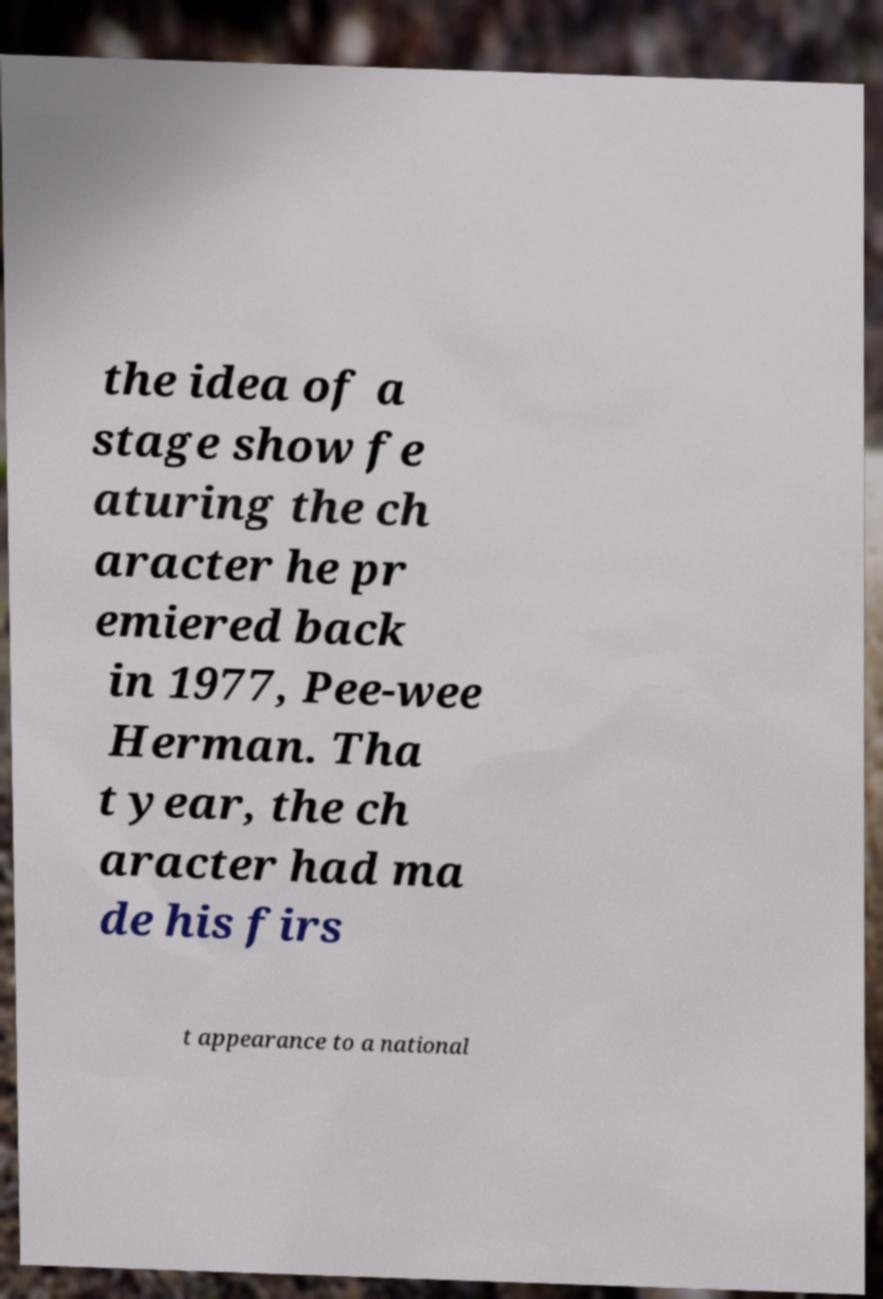Can you read and provide the text displayed in the image?This photo seems to have some interesting text. Can you extract and type it out for me? the idea of a stage show fe aturing the ch aracter he pr emiered back in 1977, Pee-wee Herman. Tha t year, the ch aracter had ma de his firs t appearance to a national 